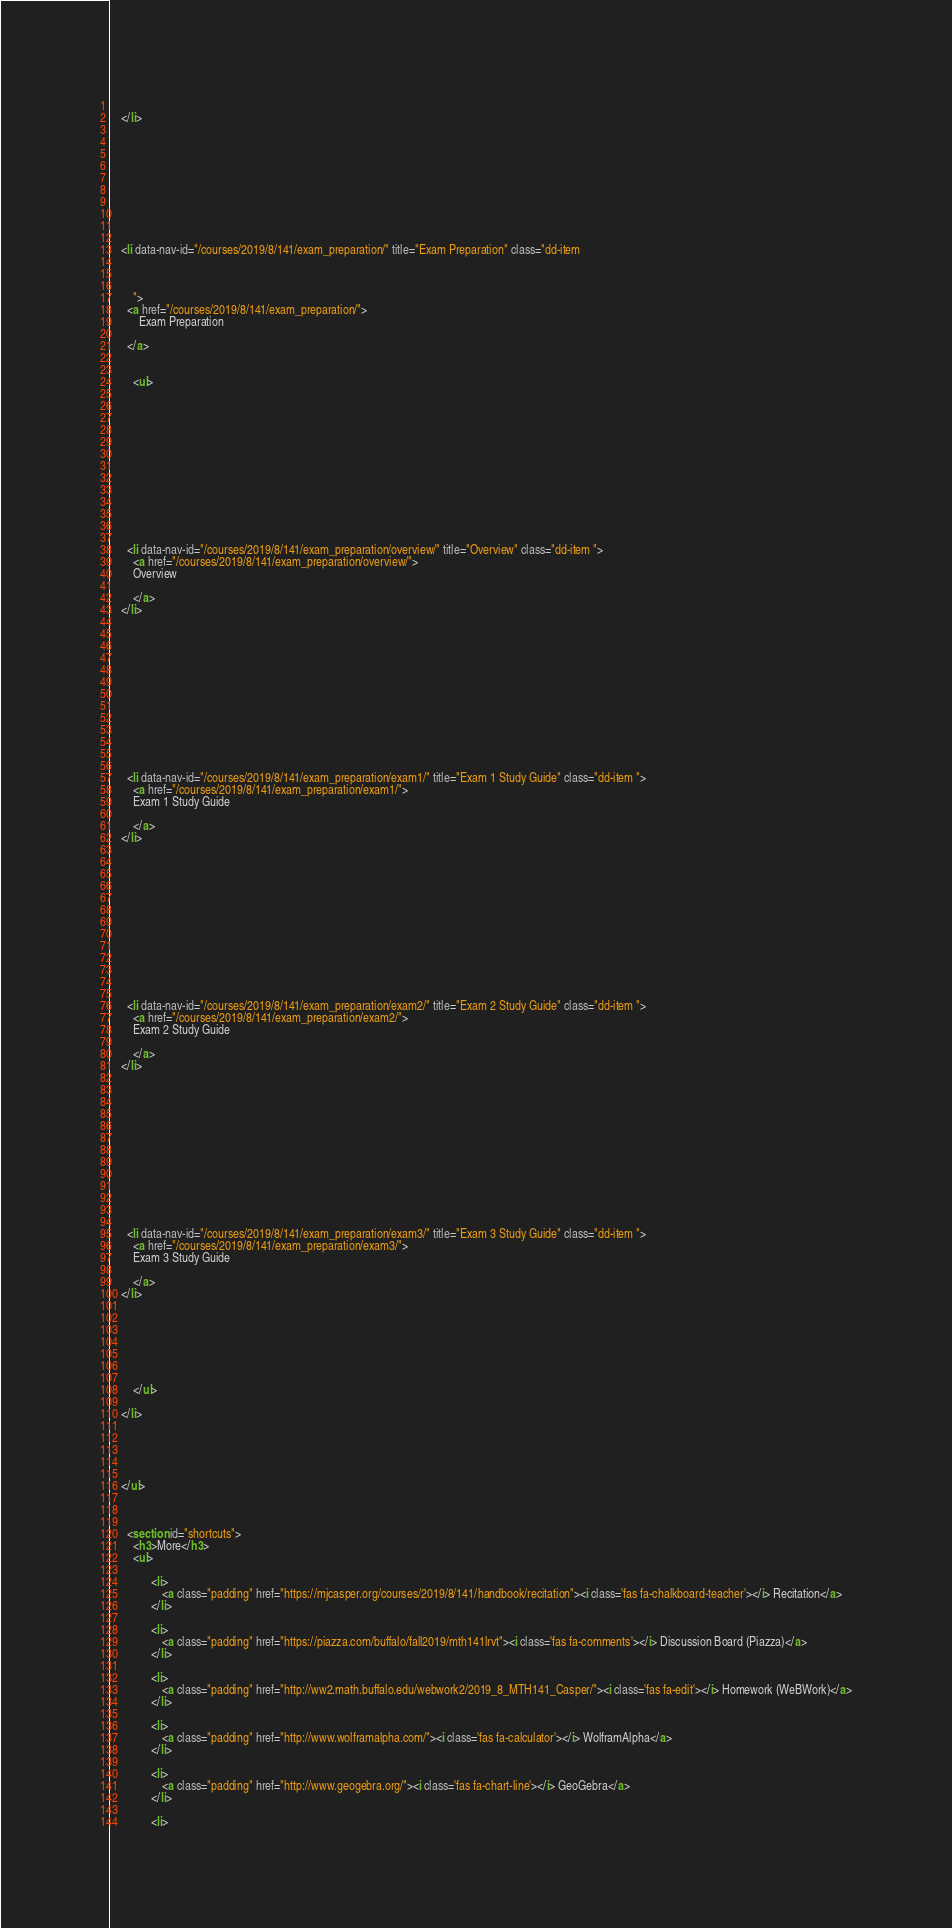Convert code to text. <code><loc_0><loc_0><loc_500><loc_500><_HTML_>              
    </li>
  
 

          
          


 
  
    
    <li data-nav-id="/courses/2019/8/141/exam_preparation/" title="Exam Preparation" class="dd-item 
        
        
        
        ">
      <a href="/courses/2019/8/141/exam_preparation/">
          Exam Preparation
          
      </a>
      
      
        <ul>
          
          
          
          
        
          
            
            


 
  
    
      <li data-nav-id="/courses/2019/8/141/exam_preparation/overview/" title="Overview" class="dd-item ">
        <a href="/courses/2019/8/141/exam_preparation/overview/">
        Overview
        
        </a>
    </li>
     
  
 

            
          
            
            


 
  
    
      <li data-nav-id="/courses/2019/8/141/exam_preparation/exam1/" title="Exam 1 Study Guide" class="dd-item ">
        <a href="/courses/2019/8/141/exam_preparation/exam1/">
        Exam 1 Study Guide
        
        </a>
    </li>
     
  
 

            
          
            
            


 
  
    
      <li data-nav-id="/courses/2019/8/141/exam_preparation/exam2/" title="Exam 2 Study Guide" class="dd-item ">
        <a href="/courses/2019/8/141/exam_preparation/exam2/">
        Exam 2 Study Guide
        
        </a>
    </li>
     
  
 

            
          
            
            


 
  
    
      <li data-nav-id="/courses/2019/8/141/exam_preparation/exam3/" title="Exam 3 Study Guide" class="dd-item ">
        <a href="/courses/2019/8/141/exam_preparation/exam3/">
        Exam 3 Study Guide
        
        </a>
    </li>
     
  
 

            
          
        
        </ul>
              
    </li>
  
 

          
         
    </ul>

    
    
      <section id="shortcuts">
        <h3>More</h3>
        <ul>
          
              <li> 
                  <a class="padding" href="https://mjcasper.org/courses/2019/8/141/handbook/recitation"><i class='fas fa-chalkboard-teacher'></i> Recitation</a>
              </li>
          
              <li> 
                  <a class="padding" href="https://piazza.com/buffalo/fall2019/mth141lrvt"><i class='fas fa-comments'></i> Discussion Board (Piazza)</a>
              </li>
          
              <li> 
                  <a class="padding" href="http://ww2.math.buffalo.edu/webwork2/2019_8_MTH141_Casper/"><i class='fas fa-edit'></i> Homework (WeBWork)</a>
              </li>
          
              <li> 
                  <a class="padding" href="http://www.wolframalpha.com/"><i class='fas fa-calculator'></i> WolframAlpha</a>
              </li>
          
              <li> 
                  <a class="padding" href="http://www.geogebra.org/"><i class='fas fa-chart-line'></i> GeoGebra</a>
              </li>
          
              <li> </code> 